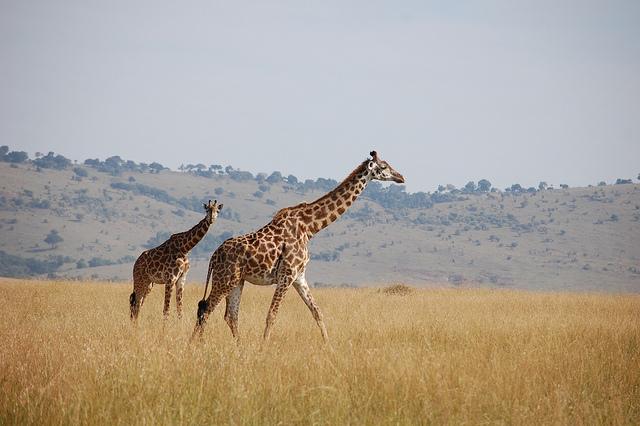What animals are these?
Write a very short answer. Giraffe. How many giraffe are there?
Write a very short answer. 2. How many animals are shown?
Write a very short answer. 2. What is the giraffe crossing?
Keep it brief. Field. Are these animals in their natural habitat?
Quick response, please. Yes. What kind of bush is that by the giraffe?
Answer briefly. Grass. What color is the grass?
Write a very short answer. Brown. How many trees are here?
Be succinct. 50. How many trees?
Answer briefly. 0. How many giraffes are there?
Give a very brief answer. 2. 